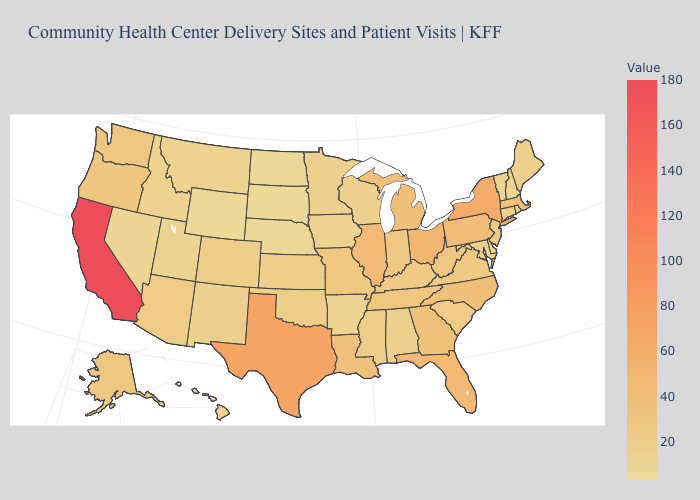Does Wisconsin have the lowest value in the MidWest?
Keep it brief. No. Does Minnesota have the lowest value in the USA?
Quick response, please. No. Does New Jersey have the highest value in the Northeast?
Quick response, please. No. Among the states that border Virginia , which have the highest value?
Be succinct. North Carolina. Does Delaware have the lowest value in the USA?
Be succinct. Yes. Does the map have missing data?
Quick response, please. No. 